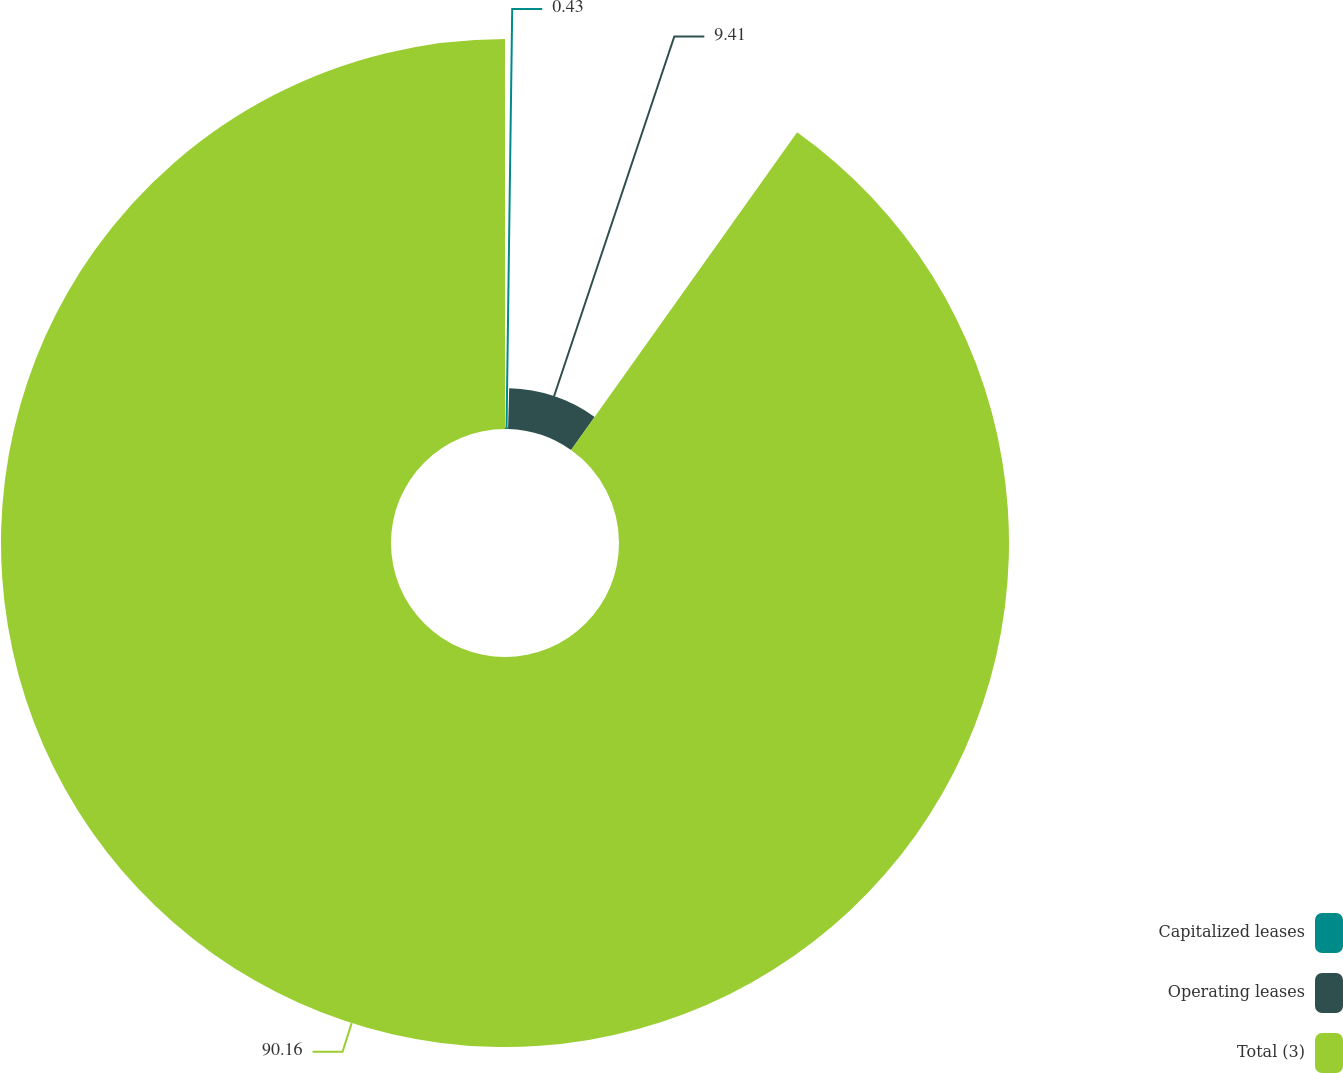Convert chart to OTSL. <chart><loc_0><loc_0><loc_500><loc_500><pie_chart><fcel>Capitalized leases<fcel>Operating leases<fcel>Total (3)<nl><fcel>0.43%<fcel>9.41%<fcel>90.16%<nl></chart> 